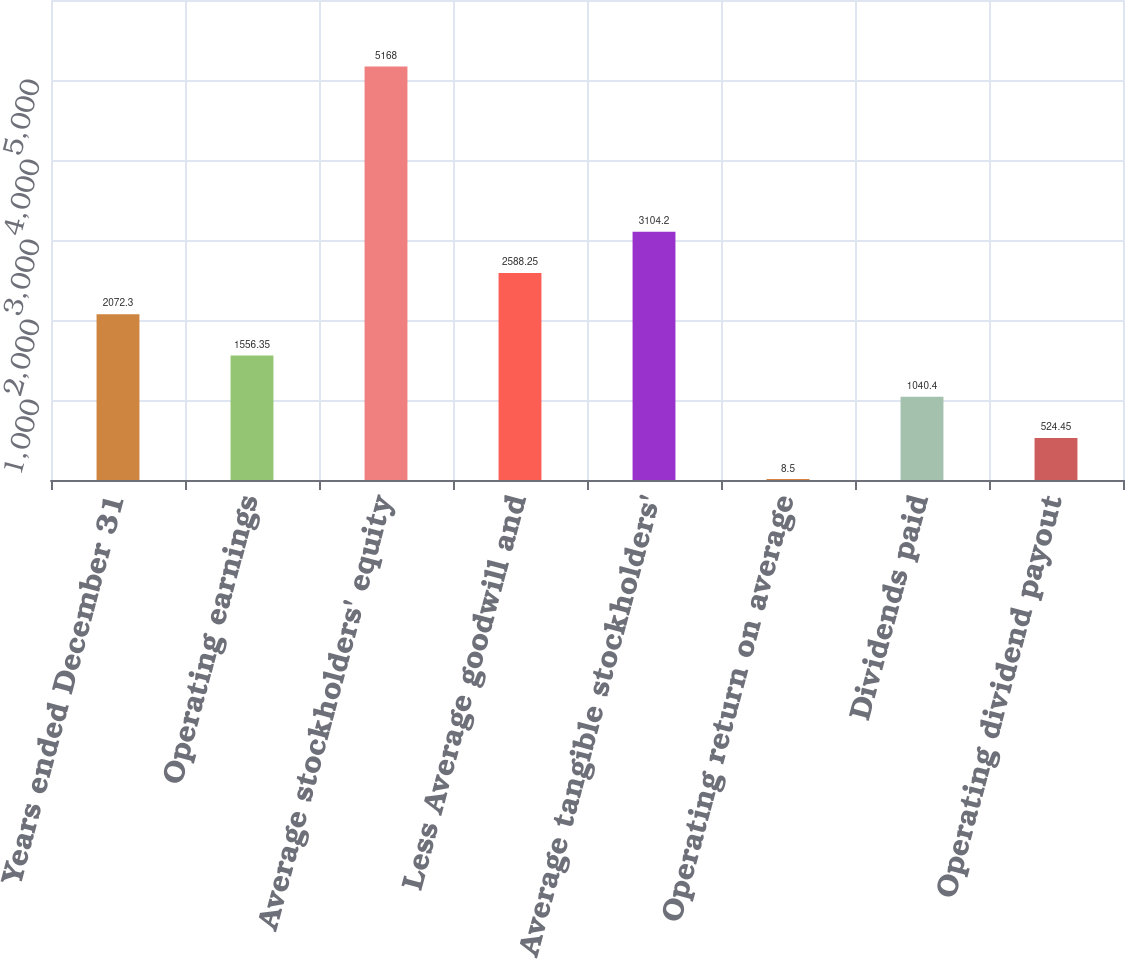<chart> <loc_0><loc_0><loc_500><loc_500><bar_chart><fcel>Years ended December 31<fcel>Operating earnings<fcel>Average stockholders' equity<fcel>Less Average goodwill and<fcel>Average tangible stockholders'<fcel>Operating return on average<fcel>Dividends paid<fcel>Operating dividend payout<nl><fcel>2072.3<fcel>1556.35<fcel>5168<fcel>2588.25<fcel>3104.2<fcel>8.5<fcel>1040.4<fcel>524.45<nl></chart> 